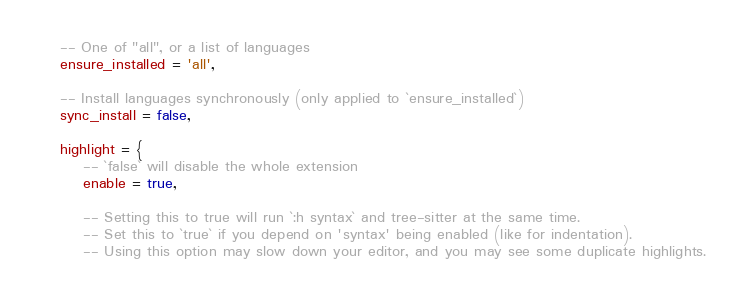Convert code to text. <code><loc_0><loc_0><loc_500><loc_500><_Lua_>    -- One of "all", or a list of languages
    ensure_installed = 'all',

    -- Install languages synchronously (only applied to `ensure_installed`)
    sync_install = false,

    highlight = {
        -- `false` will disable the whole extension
        enable = true,

        -- Setting this to true will run `:h syntax` and tree-sitter at the same time.
        -- Set this to `true` if you depend on 'syntax' being enabled (like for indentation).
        -- Using this option may slow down your editor, and you may see some duplicate highlights.</code> 